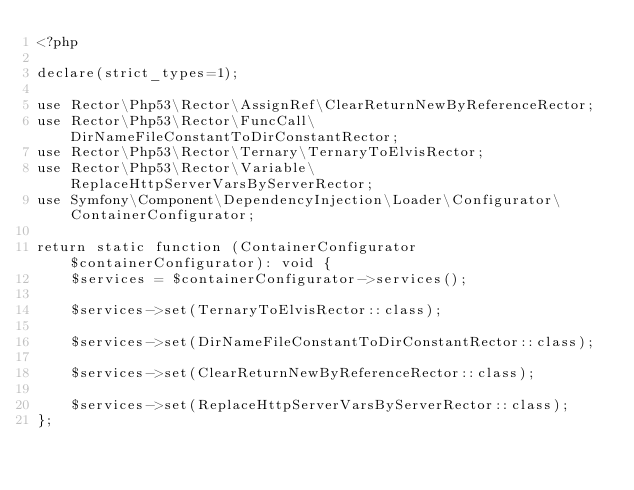Convert code to text. <code><loc_0><loc_0><loc_500><loc_500><_PHP_><?php

declare(strict_types=1);

use Rector\Php53\Rector\AssignRef\ClearReturnNewByReferenceRector;
use Rector\Php53\Rector\FuncCall\DirNameFileConstantToDirConstantRector;
use Rector\Php53\Rector\Ternary\TernaryToElvisRector;
use Rector\Php53\Rector\Variable\ReplaceHttpServerVarsByServerRector;
use Symfony\Component\DependencyInjection\Loader\Configurator\ContainerConfigurator;

return static function (ContainerConfigurator $containerConfigurator): void {
    $services = $containerConfigurator->services();

    $services->set(TernaryToElvisRector::class);

    $services->set(DirNameFileConstantToDirConstantRector::class);

    $services->set(ClearReturnNewByReferenceRector::class);

    $services->set(ReplaceHttpServerVarsByServerRector::class);
};
</code> 